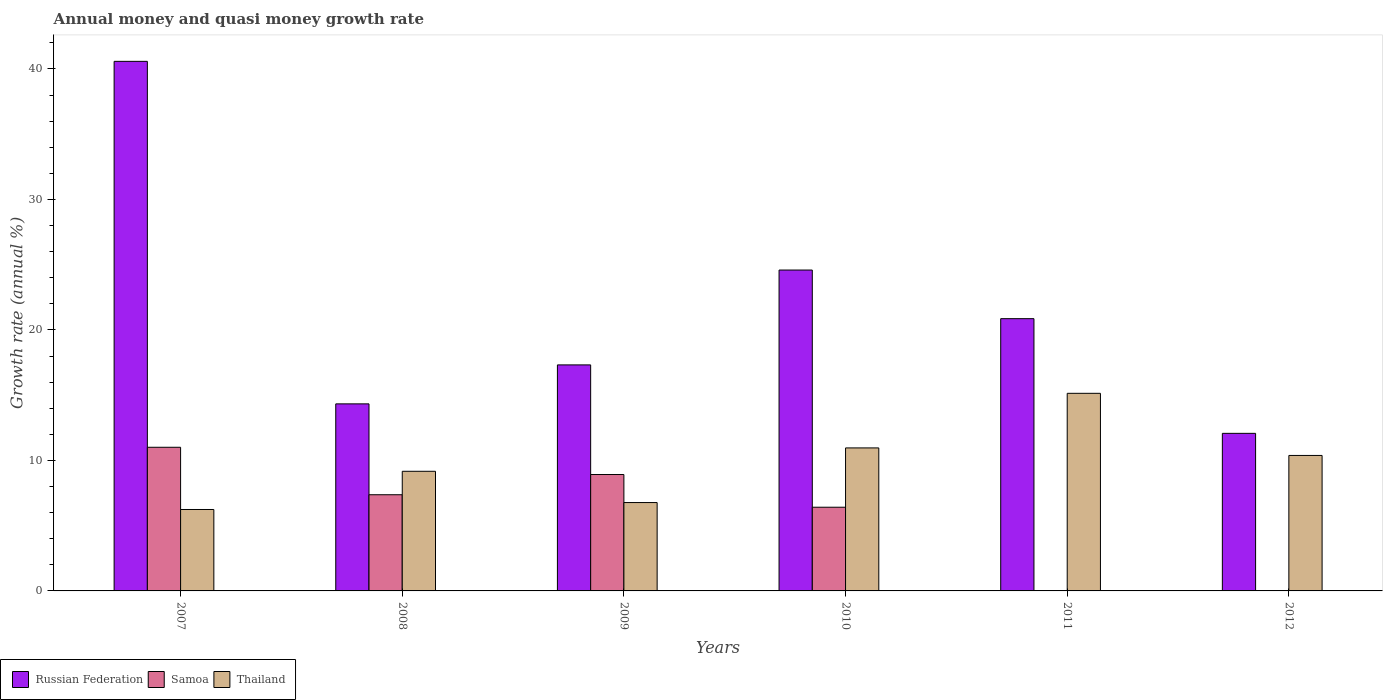Are the number of bars on each tick of the X-axis equal?
Provide a succinct answer. No. How many bars are there on the 1st tick from the left?
Offer a very short reply. 3. How many bars are there on the 6th tick from the right?
Provide a succinct answer. 3. What is the growth rate in Russian Federation in 2011?
Offer a very short reply. 20.86. Across all years, what is the maximum growth rate in Samoa?
Your response must be concise. 11.01. What is the total growth rate in Russian Federation in the graph?
Offer a very short reply. 129.76. What is the difference between the growth rate in Thailand in 2009 and that in 2011?
Your answer should be compact. -8.37. What is the difference between the growth rate in Thailand in 2010 and the growth rate in Samoa in 2009?
Keep it short and to the point. 2.04. What is the average growth rate in Samoa per year?
Keep it short and to the point. 5.62. In the year 2009, what is the difference between the growth rate in Thailand and growth rate in Russian Federation?
Offer a very short reply. -10.55. What is the ratio of the growth rate in Thailand in 2010 to that in 2012?
Your answer should be compact. 1.06. Is the growth rate in Russian Federation in 2009 less than that in 2012?
Offer a terse response. No. What is the difference between the highest and the second highest growth rate in Samoa?
Offer a very short reply. 2.09. What is the difference between the highest and the lowest growth rate in Samoa?
Your response must be concise. 11.01. In how many years, is the growth rate in Russian Federation greater than the average growth rate in Russian Federation taken over all years?
Provide a short and direct response. 2. Is it the case that in every year, the sum of the growth rate in Thailand and growth rate in Russian Federation is greater than the growth rate in Samoa?
Keep it short and to the point. Yes. How many bars are there?
Your answer should be compact. 16. How many years are there in the graph?
Give a very brief answer. 6. What is the difference between two consecutive major ticks on the Y-axis?
Your answer should be very brief. 10. Are the values on the major ticks of Y-axis written in scientific E-notation?
Make the answer very short. No. How many legend labels are there?
Ensure brevity in your answer.  3. How are the legend labels stacked?
Your answer should be compact. Horizontal. What is the title of the graph?
Your response must be concise. Annual money and quasi money growth rate. What is the label or title of the X-axis?
Offer a terse response. Years. What is the label or title of the Y-axis?
Offer a terse response. Growth rate (annual %). What is the Growth rate (annual %) of Russian Federation in 2007?
Make the answer very short. 40.58. What is the Growth rate (annual %) in Samoa in 2007?
Keep it short and to the point. 11.01. What is the Growth rate (annual %) of Thailand in 2007?
Give a very brief answer. 6.24. What is the Growth rate (annual %) in Russian Federation in 2008?
Your answer should be very brief. 14.33. What is the Growth rate (annual %) of Samoa in 2008?
Ensure brevity in your answer.  7.37. What is the Growth rate (annual %) in Thailand in 2008?
Keep it short and to the point. 9.17. What is the Growth rate (annual %) in Russian Federation in 2009?
Ensure brevity in your answer.  17.32. What is the Growth rate (annual %) in Samoa in 2009?
Your answer should be compact. 8.92. What is the Growth rate (annual %) of Thailand in 2009?
Provide a succinct answer. 6.77. What is the Growth rate (annual %) of Russian Federation in 2010?
Give a very brief answer. 24.59. What is the Growth rate (annual %) of Samoa in 2010?
Provide a succinct answer. 6.41. What is the Growth rate (annual %) in Thailand in 2010?
Make the answer very short. 10.96. What is the Growth rate (annual %) in Russian Federation in 2011?
Offer a very short reply. 20.86. What is the Growth rate (annual %) of Samoa in 2011?
Make the answer very short. 0. What is the Growth rate (annual %) in Thailand in 2011?
Provide a succinct answer. 15.14. What is the Growth rate (annual %) of Russian Federation in 2012?
Your answer should be very brief. 12.07. What is the Growth rate (annual %) in Thailand in 2012?
Offer a very short reply. 10.38. Across all years, what is the maximum Growth rate (annual %) in Russian Federation?
Your answer should be very brief. 40.58. Across all years, what is the maximum Growth rate (annual %) of Samoa?
Your answer should be very brief. 11.01. Across all years, what is the maximum Growth rate (annual %) in Thailand?
Your answer should be very brief. 15.14. Across all years, what is the minimum Growth rate (annual %) of Russian Federation?
Offer a very short reply. 12.07. Across all years, what is the minimum Growth rate (annual %) of Samoa?
Keep it short and to the point. 0. Across all years, what is the minimum Growth rate (annual %) of Thailand?
Provide a succinct answer. 6.24. What is the total Growth rate (annual %) of Russian Federation in the graph?
Make the answer very short. 129.76. What is the total Growth rate (annual %) of Samoa in the graph?
Give a very brief answer. 33.71. What is the total Growth rate (annual %) in Thailand in the graph?
Make the answer very short. 58.66. What is the difference between the Growth rate (annual %) in Russian Federation in 2007 and that in 2008?
Keep it short and to the point. 26.25. What is the difference between the Growth rate (annual %) of Samoa in 2007 and that in 2008?
Your response must be concise. 3.64. What is the difference between the Growth rate (annual %) of Thailand in 2007 and that in 2008?
Provide a short and direct response. -2.93. What is the difference between the Growth rate (annual %) of Russian Federation in 2007 and that in 2009?
Make the answer very short. 23.26. What is the difference between the Growth rate (annual %) in Samoa in 2007 and that in 2009?
Your response must be concise. 2.09. What is the difference between the Growth rate (annual %) in Thailand in 2007 and that in 2009?
Provide a short and direct response. -0.53. What is the difference between the Growth rate (annual %) of Russian Federation in 2007 and that in 2010?
Make the answer very short. 15.99. What is the difference between the Growth rate (annual %) of Samoa in 2007 and that in 2010?
Keep it short and to the point. 4.59. What is the difference between the Growth rate (annual %) of Thailand in 2007 and that in 2010?
Offer a terse response. -4.72. What is the difference between the Growth rate (annual %) in Russian Federation in 2007 and that in 2011?
Offer a terse response. 19.72. What is the difference between the Growth rate (annual %) in Thailand in 2007 and that in 2011?
Your answer should be very brief. -8.9. What is the difference between the Growth rate (annual %) in Russian Federation in 2007 and that in 2012?
Your answer should be compact. 28.51. What is the difference between the Growth rate (annual %) of Thailand in 2007 and that in 2012?
Make the answer very short. -4.14. What is the difference between the Growth rate (annual %) of Russian Federation in 2008 and that in 2009?
Offer a terse response. -2.99. What is the difference between the Growth rate (annual %) of Samoa in 2008 and that in 2009?
Give a very brief answer. -1.55. What is the difference between the Growth rate (annual %) of Thailand in 2008 and that in 2009?
Make the answer very short. 2.4. What is the difference between the Growth rate (annual %) in Russian Federation in 2008 and that in 2010?
Make the answer very short. -10.26. What is the difference between the Growth rate (annual %) in Samoa in 2008 and that in 2010?
Your response must be concise. 0.96. What is the difference between the Growth rate (annual %) of Thailand in 2008 and that in 2010?
Your answer should be very brief. -1.79. What is the difference between the Growth rate (annual %) of Russian Federation in 2008 and that in 2011?
Offer a very short reply. -6.53. What is the difference between the Growth rate (annual %) in Thailand in 2008 and that in 2011?
Give a very brief answer. -5.98. What is the difference between the Growth rate (annual %) in Russian Federation in 2008 and that in 2012?
Your answer should be compact. 2.26. What is the difference between the Growth rate (annual %) of Thailand in 2008 and that in 2012?
Your response must be concise. -1.21. What is the difference between the Growth rate (annual %) of Russian Federation in 2009 and that in 2010?
Keep it short and to the point. -7.27. What is the difference between the Growth rate (annual %) of Samoa in 2009 and that in 2010?
Your answer should be very brief. 2.51. What is the difference between the Growth rate (annual %) of Thailand in 2009 and that in 2010?
Keep it short and to the point. -4.19. What is the difference between the Growth rate (annual %) in Russian Federation in 2009 and that in 2011?
Make the answer very short. -3.54. What is the difference between the Growth rate (annual %) in Thailand in 2009 and that in 2011?
Offer a terse response. -8.37. What is the difference between the Growth rate (annual %) of Russian Federation in 2009 and that in 2012?
Provide a succinct answer. 5.25. What is the difference between the Growth rate (annual %) of Thailand in 2009 and that in 2012?
Keep it short and to the point. -3.61. What is the difference between the Growth rate (annual %) of Russian Federation in 2010 and that in 2011?
Keep it short and to the point. 3.73. What is the difference between the Growth rate (annual %) of Thailand in 2010 and that in 2011?
Provide a succinct answer. -4.18. What is the difference between the Growth rate (annual %) of Russian Federation in 2010 and that in 2012?
Provide a short and direct response. 12.51. What is the difference between the Growth rate (annual %) in Thailand in 2010 and that in 2012?
Provide a short and direct response. 0.58. What is the difference between the Growth rate (annual %) in Russian Federation in 2011 and that in 2012?
Give a very brief answer. 8.79. What is the difference between the Growth rate (annual %) in Thailand in 2011 and that in 2012?
Make the answer very short. 4.76. What is the difference between the Growth rate (annual %) of Russian Federation in 2007 and the Growth rate (annual %) of Samoa in 2008?
Your response must be concise. 33.21. What is the difference between the Growth rate (annual %) in Russian Federation in 2007 and the Growth rate (annual %) in Thailand in 2008?
Provide a short and direct response. 31.41. What is the difference between the Growth rate (annual %) in Samoa in 2007 and the Growth rate (annual %) in Thailand in 2008?
Provide a succinct answer. 1.84. What is the difference between the Growth rate (annual %) of Russian Federation in 2007 and the Growth rate (annual %) of Samoa in 2009?
Provide a short and direct response. 31.66. What is the difference between the Growth rate (annual %) in Russian Federation in 2007 and the Growth rate (annual %) in Thailand in 2009?
Ensure brevity in your answer.  33.81. What is the difference between the Growth rate (annual %) of Samoa in 2007 and the Growth rate (annual %) of Thailand in 2009?
Offer a very short reply. 4.24. What is the difference between the Growth rate (annual %) of Russian Federation in 2007 and the Growth rate (annual %) of Samoa in 2010?
Provide a succinct answer. 34.17. What is the difference between the Growth rate (annual %) in Russian Federation in 2007 and the Growth rate (annual %) in Thailand in 2010?
Offer a very short reply. 29.62. What is the difference between the Growth rate (annual %) in Samoa in 2007 and the Growth rate (annual %) in Thailand in 2010?
Provide a short and direct response. 0.05. What is the difference between the Growth rate (annual %) in Russian Federation in 2007 and the Growth rate (annual %) in Thailand in 2011?
Offer a terse response. 25.44. What is the difference between the Growth rate (annual %) of Samoa in 2007 and the Growth rate (annual %) of Thailand in 2011?
Your answer should be compact. -4.14. What is the difference between the Growth rate (annual %) of Russian Federation in 2007 and the Growth rate (annual %) of Thailand in 2012?
Your answer should be very brief. 30.2. What is the difference between the Growth rate (annual %) in Samoa in 2007 and the Growth rate (annual %) in Thailand in 2012?
Give a very brief answer. 0.63. What is the difference between the Growth rate (annual %) of Russian Federation in 2008 and the Growth rate (annual %) of Samoa in 2009?
Your answer should be very brief. 5.41. What is the difference between the Growth rate (annual %) of Russian Federation in 2008 and the Growth rate (annual %) of Thailand in 2009?
Ensure brevity in your answer.  7.56. What is the difference between the Growth rate (annual %) of Samoa in 2008 and the Growth rate (annual %) of Thailand in 2009?
Provide a succinct answer. 0.6. What is the difference between the Growth rate (annual %) in Russian Federation in 2008 and the Growth rate (annual %) in Samoa in 2010?
Ensure brevity in your answer.  7.92. What is the difference between the Growth rate (annual %) of Russian Federation in 2008 and the Growth rate (annual %) of Thailand in 2010?
Give a very brief answer. 3.38. What is the difference between the Growth rate (annual %) of Samoa in 2008 and the Growth rate (annual %) of Thailand in 2010?
Provide a succinct answer. -3.59. What is the difference between the Growth rate (annual %) of Russian Federation in 2008 and the Growth rate (annual %) of Thailand in 2011?
Your response must be concise. -0.81. What is the difference between the Growth rate (annual %) of Samoa in 2008 and the Growth rate (annual %) of Thailand in 2011?
Ensure brevity in your answer.  -7.77. What is the difference between the Growth rate (annual %) in Russian Federation in 2008 and the Growth rate (annual %) in Thailand in 2012?
Make the answer very short. 3.95. What is the difference between the Growth rate (annual %) of Samoa in 2008 and the Growth rate (annual %) of Thailand in 2012?
Keep it short and to the point. -3.01. What is the difference between the Growth rate (annual %) of Russian Federation in 2009 and the Growth rate (annual %) of Samoa in 2010?
Your answer should be very brief. 10.91. What is the difference between the Growth rate (annual %) in Russian Federation in 2009 and the Growth rate (annual %) in Thailand in 2010?
Your answer should be compact. 6.36. What is the difference between the Growth rate (annual %) in Samoa in 2009 and the Growth rate (annual %) in Thailand in 2010?
Provide a short and direct response. -2.04. What is the difference between the Growth rate (annual %) in Russian Federation in 2009 and the Growth rate (annual %) in Thailand in 2011?
Your answer should be compact. 2.18. What is the difference between the Growth rate (annual %) in Samoa in 2009 and the Growth rate (annual %) in Thailand in 2011?
Your answer should be compact. -6.22. What is the difference between the Growth rate (annual %) in Russian Federation in 2009 and the Growth rate (annual %) in Thailand in 2012?
Make the answer very short. 6.94. What is the difference between the Growth rate (annual %) in Samoa in 2009 and the Growth rate (annual %) in Thailand in 2012?
Give a very brief answer. -1.46. What is the difference between the Growth rate (annual %) in Russian Federation in 2010 and the Growth rate (annual %) in Thailand in 2011?
Provide a succinct answer. 9.45. What is the difference between the Growth rate (annual %) of Samoa in 2010 and the Growth rate (annual %) of Thailand in 2011?
Ensure brevity in your answer.  -8.73. What is the difference between the Growth rate (annual %) in Russian Federation in 2010 and the Growth rate (annual %) in Thailand in 2012?
Provide a succinct answer. 14.21. What is the difference between the Growth rate (annual %) of Samoa in 2010 and the Growth rate (annual %) of Thailand in 2012?
Offer a terse response. -3.97. What is the difference between the Growth rate (annual %) in Russian Federation in 2011 and the Growth rate (annual %) in Thailand in 2012?
Give a very brief answer. 10.48. What is the average Growth rate (annual %) of Russian Federation per year?
Make the answer very short. 21.63. What is the average Growth rate (annual %) in Samoa per year?
Keep it short and to the point. 5.62. What is the average Growth rate (annual %) of Thailand per year?
Provide a succinct answer. 9.78. In the year 2007, what is the difference between the Growth rate (annual %) of Russian Federation and Growth rate (annual %) of Samoa?
Offer a very short reply. 29.57. In the year 2007, what is the difference between the Growth rate (annual %) in Russian Federation and Growth rate (annual %) in Thailand?
Your answer should be compact. 34.34. In the year 2007, what is the difference between the Growth rate (annual %) of Samoa and Growth rate (annual %) of Thailand?
Keep it short and to the point. 4.77. In the year 2008, what is the difference between the Growth rate (annual %) of Russian Federation and Growth rate (annual %) of Samoa?
Keep it short and to the point. 6.96. In the year 2008, what is the difference between the Growth rate (annual %) of Russian Federation and Growth rate (annual %) of Thailand?
Your answer should be compact. 5.17. In the year 2008, what is the difference between the Growth rate (annual %) of Samoa and Growth rate (annual %) of Thailand?
Your answer should be compact. -1.8. In the year 2009, what is the difference between the Growth rate (annual %) in Russian Federation and Growth rate (annual %) in Samoa?
Provide a succinct answer. 8.4. In the year 2009, what is the difference between the Growth rate (annual %) in Russian Federation and Growth rate (annual %) in Thailand?
Keep it short and to the point. 10.55. In the year 2009, what is the difference between the Growth rate (annual %) in Samoa and Growth rate (annual %) in Thailand?
Your answer should be very brief. 2.15. In the year 2010, what is the difference between the Growth rate (annual %) in Russian Federation and Growth rate (annual %) in Samoa?
Give a very brief answer. 18.18. In the year 2010, what is the difference between the Growth rate (annual %) in Russian Federation and Growth rate (annual %) in Thailand?
Provide a short and direct response. 13.63. In the year 2010, what is the difference between the Growth rate (annual %) of Samoa and Growth rate (annual %) of Thailand?
Your response must be concise. -4.54. In the year 2011, what is the difference between the Growth rate (annual %) of Russian Federation and Growth rate (annual %) of Thailand?
Keep it short and to the point. 5.72. In the year 2012, what is the difference between the Growth rate (annual %) in Russian Federation and Growth rate (annual %) in Thailand?
Make the answer very short. 1.69. What is the ratio of the Growth rate (annual %) in Russian Federation in 2007 to that in 2008?
Give a very brief answer. 2.83. What is the ratio of the Growth rate (annual %) of Samoa in 2007 to that in 2008?
Ensure brevity in your answer.  1.49. What is the ratio of the Growth rate (annual %) in Thailand in 2007 to that in 2008?
Keep it short and to the point. 0.68. What is the ratio of the Growth rate (annual %) in Russian Federation in 2007 to that in 2009?
Provide a succinct answer. 2.34. What is the ratio of the Growth rate (annual %) of Samoa in 2007 to that in 2009?
Keep it short and to the point. 1.23. What is the ratio of the Growth rate (annual %) in Thailand in 2007 to that in 2009?
Offer a very short reply. 0.92. What is the ratio of the Growth rate (annual %) in Russian Federation in 2007 to that in 2010?
Your answer should be very brief. 1.65. What is the ratio of the Growth rate (annual %) of Samoa in 2007 to that in 2010?
Make the answer very short. 1.72. What is the ratio of the Growth rate (annual %) in Thailand in 2007 to that in 2010?
Offer a very short reply. 0.57. What is the ratio of the Growth rate (annual %) in Russian Federation in 2007 to that in 2011?
Keep it short and to the point. 1.95. What is the ratio of the Growth rate (annual %) of Thailand in 2007 to that in 2011?
Make the answer very short. 0.41. What is the ratio of the Growth rate (annual %) in Russian Federation in 2007 to that in 2012?
Provide a succinct answer. 3.36. What is the ratio of the Growth rate (annual %) in Thailand in 2007 to that in 2012?
Offer a very short reply. 0.6. What is the ratio of the Growth rate (annual %) in Russian Federation in 2008 to that in 2009?
Provide a succinct answer. 0.83. What is the ratio of the Growth rate (annual %) in Samoa in 2008 to that in 2009?
Your response must be concise. 0.83. What is the ratio of the Growth rate (annual %) of Thailand in 2008 to that in 2009?
Give a very brief answer. 1.35. What is the ratio of the Growth rate (annual %) in Russian Federation in 2008 to that in 2010?
Ensure brevity in your answer.  0.58. What is the ratio of the Growth rate (annual %) of Samoa in 2008 to that in 2010?
Your answer should be compact. 1.15. What is the ratio of the Growth rate (annual %) in Thailand in 2008 to that in 2010?
Your answer should be very brief. 0.84. What is the ratio of the Growth rate (annual %) of Russian Federation in 2008 to that in 2011?
Provide a succinct answer. 0.69. What is the ratio of the Growth rate (annual %) in Thailand in 2008 to that in 2011?
Provide a short and direct response. 0.61. What is the ratio of the Growth rate (annual %) in Russian Federation in 2008 to that in 2012?
Offer a very short reply. 1.19. What is the ratio of the Growth rate (annual %) in Thailand in 2008 to that in 2012?
Make the answer very short. 0.88. What is the ratio of the Growth rate (annual %) in Russian Federation in 2009 to that in 2010?
Your answer should be very brief. 0.7. What is the ratio of the Growth rate (annual %) of Samoa in 2009 to that in 2010?
Provide a short and direct response. 1.39. What is the ratio of the Growth rate (annual %) in Thailand in 2009 to that in 2010?
Offer a very short reply. 0.62. What is the ratio of the Growth rate (annual %) of Russian Federation in 2009 to that in 2011?
Provide a short and direct response. 0.83. What is the ratio of the Growth rate (annual %) of Thailand in 2009 to that in 2011?
Provide a short and direct response. 0.45. What is the ratio of the Growth rate (annual %) of Russian Federation in 2009 to that in 2012?
Give a very brief answer. 1.43. What is the ratio of the Growth rate (annual %) of Thailand in 2009 to that in 2012?
Offer a very short reply. 0.65. What is the ratio of the Growth rate (annual %) in Russian Federation in 2010 to that in 2011?
Your answer should be compact. 1.18. What is the ratio of the Growth rate (annual %) of Thailand in 2010 to that in 2011?
Offer a very short reply. 0.72. What is the ratio of the Growth rate (annual %) in Russian Federation in 2010 to that in 2012?
Keep it short and to the point. 2.04. What is the ratio of the Growth rate (annual %) in Thailand in 2010 to that in 2012?
Offer a very short reply. 1.06. What is the ratio of the Growth rate (annual %) in Russian Federation in 2011 to that in 2012?
Your answer should be compact. 1.73. What is the ratio of the Growth rate (annual %) in Thailand in 2011 to that in 2012?
Give a very brief answer. 1.46. What is the difference between the highest and the second highest Growth rate (annual %) of Russian Federation?
Provide a succinct answer. 15.99. What is the difference between the highest and the second highest Growth rate (annual %) of Samoa?
Ensure brevity in your answer.  2.09. What is the difference between the highest and the second highest Growth rate (annual %) in Thailand?
Make the answer very short. 4.18. What is the difference between the highest and the lowest Growth rate (annual %) in Russian Federation?
Make the answer very short. 28.51. What is the difference between the highest and the lowest Growth rate (annual %) in Samoa?
Your answer should be compact. 11.01. What is the difference between the highest and the lowest Growth rate (annual %) in Thailand?
Offer a terse response. 8.9. 